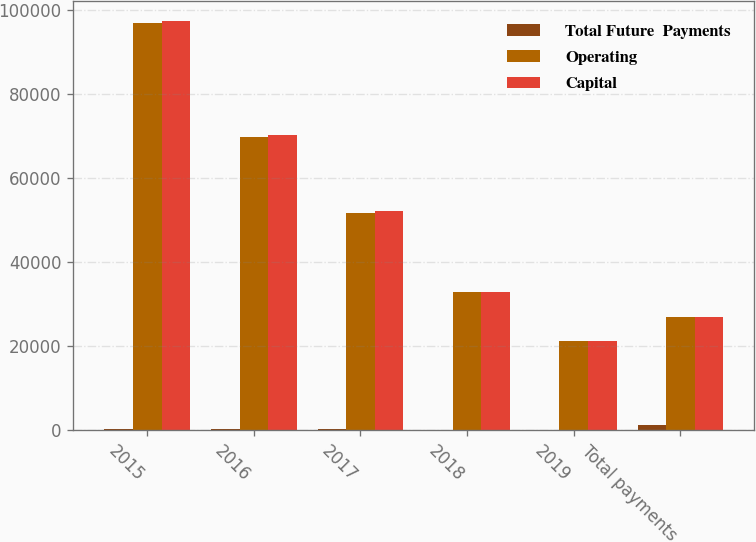Convert chart. <chart><loc_0><loc_0><loc_500><loc_500><stacked_bar_chart><ecel><fcel>2015<fcel>2016<fcel>2017<fcel>2018<fcel>2019<fcel>Total payments<nl><fcel>Total Future  Payments<fcel>441<fcel>448<fcel>323<fcel>26<fcel>10<fcel>1248<nl><fcel>Operating<fcel>96873<fcel>69875<fcel>51811<fcel>32985<fcel>21164<fcel>27079.5<nl><fcel>Capital<fcel>97314<fcel>70323<fcel>52134<fcel>33011<fcel>21174<fcel>27079.5<nl></chart> 